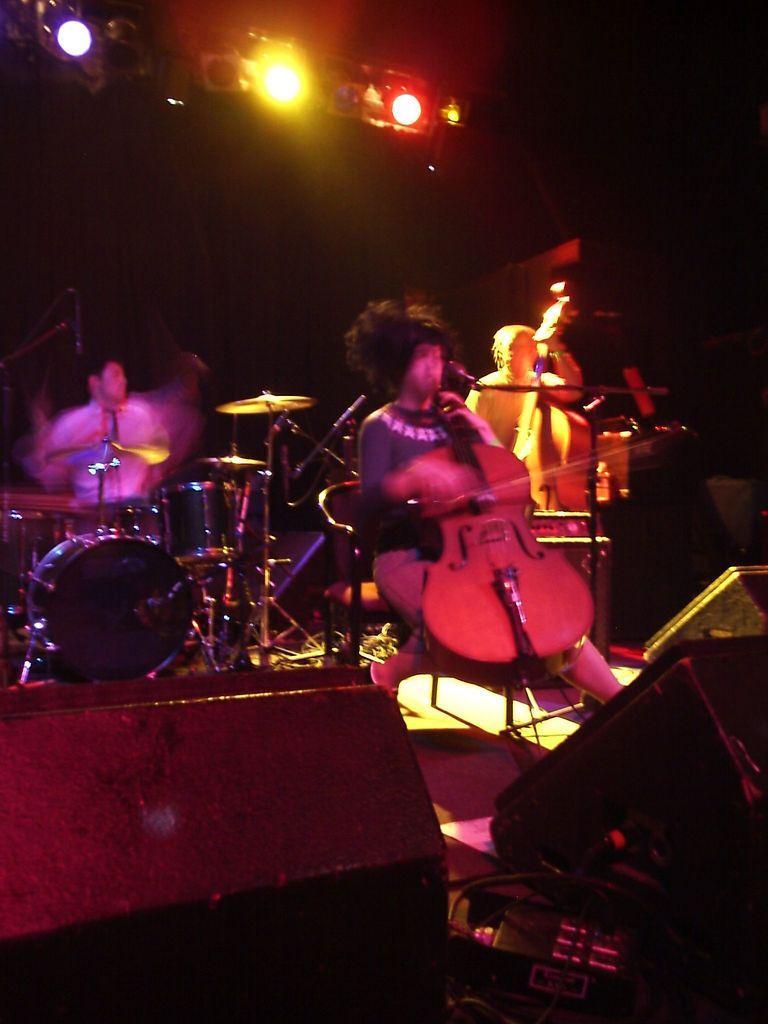Describe this image in one or two sentences. This is the picture of some people playing some musical instruments which are in front of them and there are some speakers and lights too. 